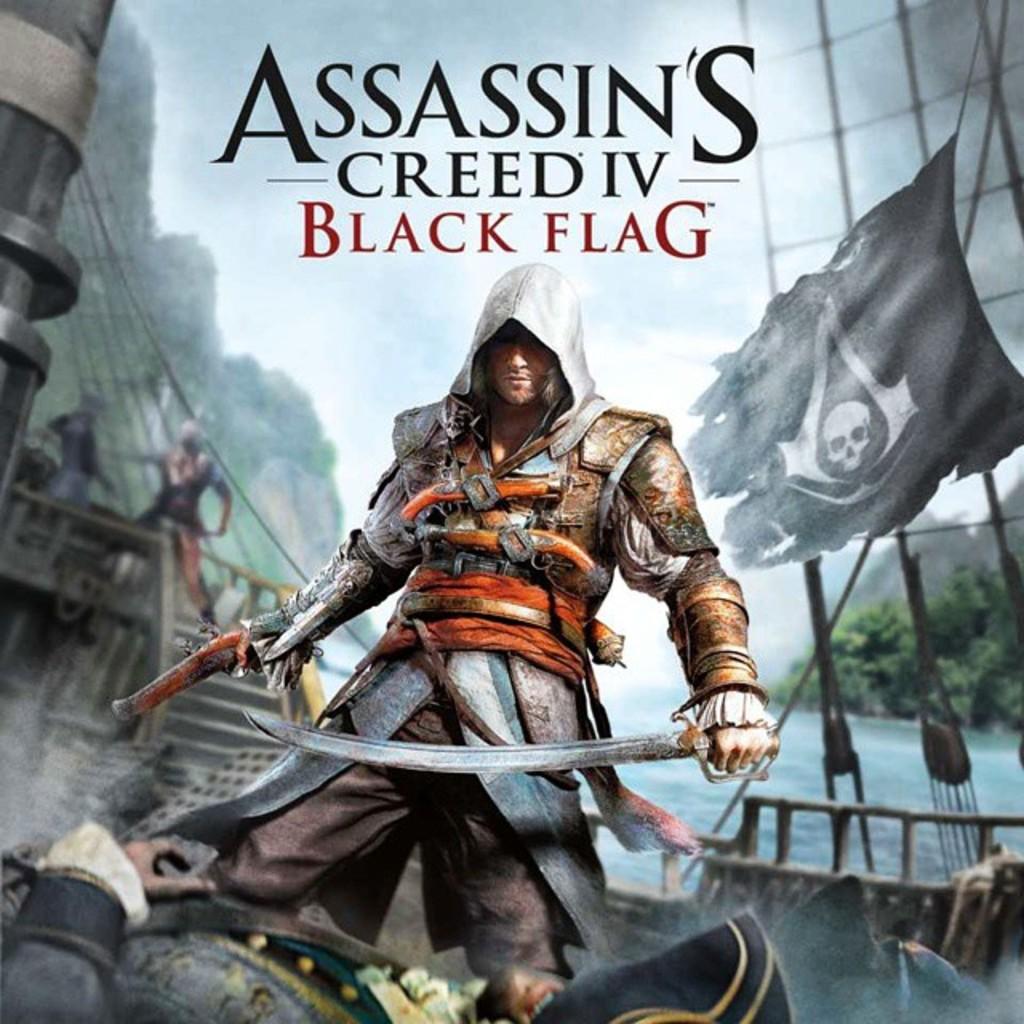What is the name of this game?
Provide a succinct answer. Assassin's creed iv black flag. What is this game called?
Offer a very short reply. Assassin's creed iv black flag. 